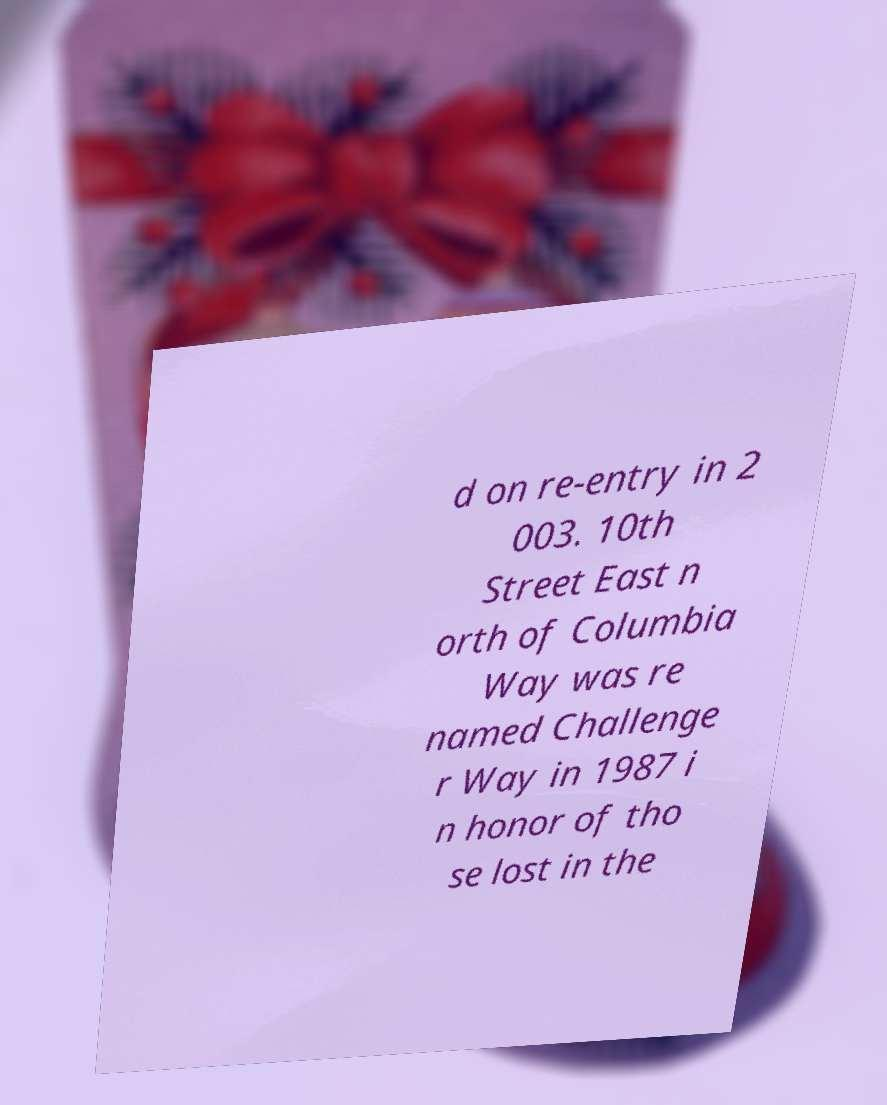For documentation purposes, I need the text within this image transcribed. Could you provide that? d on re-entry in 2 003. 10th Street East n orth of Columbia Way was re named Challenge r Way in 1987 i n honor of tho se lost in the 